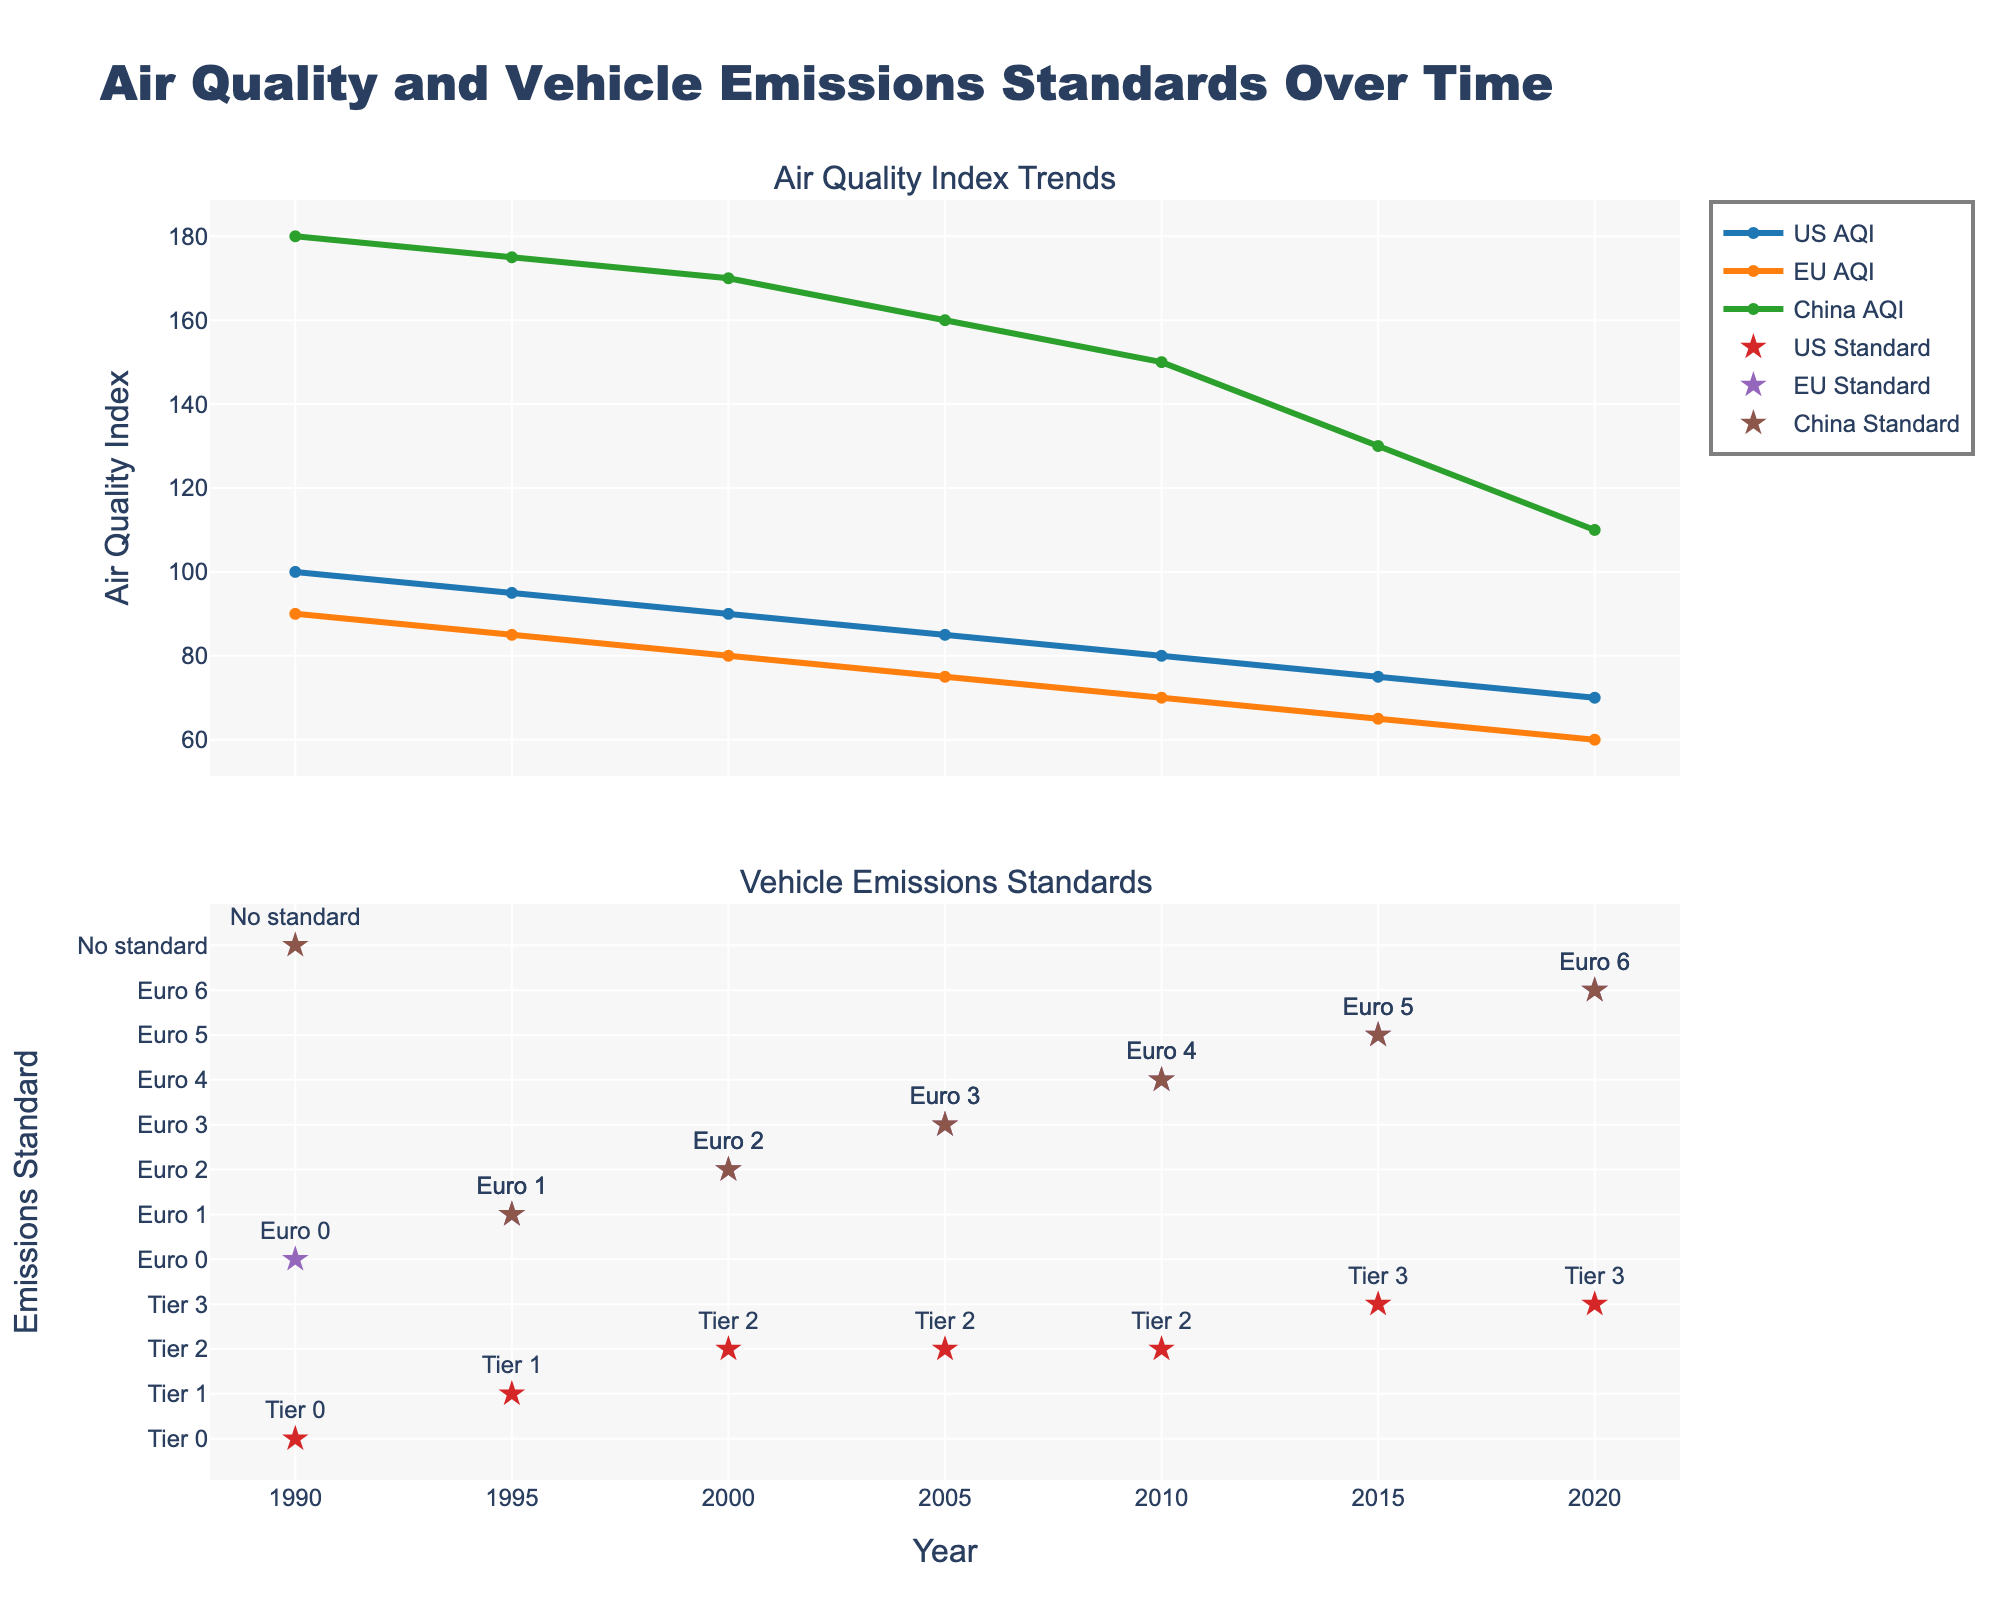What is the title of the upper subplot? The title is typically located at the top of each subplot. For the upper subplot, it clearly states the subject matter it covers.
Answer: Air Quality Index Trends Which country had the highest AQI in 1990? On the AQI line chart, look for the y-values of the different countries for the year 1990. The line representing China is the highest at this point.
Answer: China How did the AQI of China change between 2000 and 2020? Find the AQI value for China in both 2000 and 2020 on the line chart and subtract the 2020 value from the 2000 value (170 - 110).
Answer: Decreased by 60 Compare the AQI trend of the US and EU from 1990 to 2020. Which one had a more significant decrease? Look at the difference between the AQI values in 1990 and 2020 for both the US and EU. Calculate the difference for each (US: 100-70=30, EU: 90-60=30). Both countries show a decrease of 30, hence it's equal.
Answer: Equal How often did the vehicle emissions standards change in the US between 1990 and 2020? Count the number of unique vehicle emissions standards listed in the lower subplot for the US within the years specified. The changes occurred from Tier 0 to Tier 1, Tier 1 to Tier 2, and Tier 2 to Tier 3.
Answer: Three times What is the difference in AQI between the US and China in 2010? Find the AQI values for both US and China for the year 2010 on the line chart and subtract the US value from the China value (150 - 80).
Answer: 70 Which region showed the lowest AQI in 2020? Look at the AQI values for all regions in 2020 and identify the lowest value. The EU has the lowest value.
Answer: EU What was the vehicle emission standard in the EU in 2015? Check the custom markers in the lower subplot for the year 2015 and find the label for the EU. It reads Euro 5.
Answer: Euro 5 Between 1990 and 2020, which country shows a clear pattern where stricter vehicle emissions standards correlate with AQI improvement? Observe the trend lines and standards changes. The US and EU both show a substantial decrease in AQI along with stricter standards. However, the US shows a direct improvement, especially post-2000, when Tier 2 was implemented.
Answer: US What is the difference in AQI between EU and China in 1995? Subtract the AQI value of the EU from that of China for the year 1995 (175 - 85).
Answer: 90 